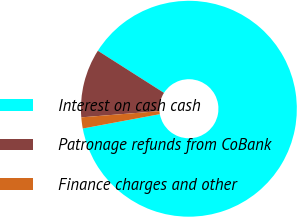<chart> <loc_0><loc_0><loc_500><loc_500><pie_chart><fcel>Interest on cash cash<fcel>Patronage refunds from CoBank<fcel>Finance charges and other<nl><fcel>88.04%<fcel>10.3%<fcel>1.66%<nl></chart> 